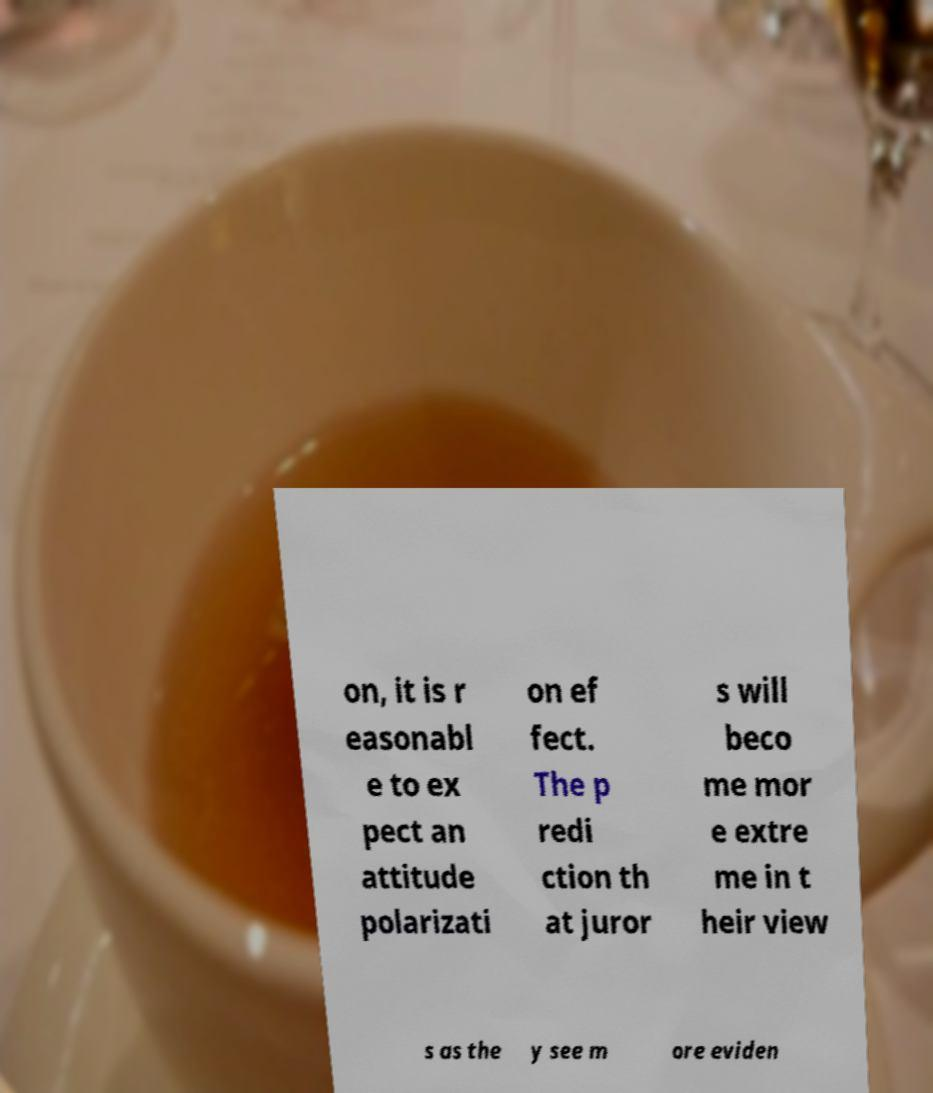I need the written content from this picture converted into text. Can you do that? on, it is r easonabl e to ex pect an attitude polarizati on ef fect. The p redi ction th at juror s will beco me mor e extre me in t heir view s as the y see m ore eviden 